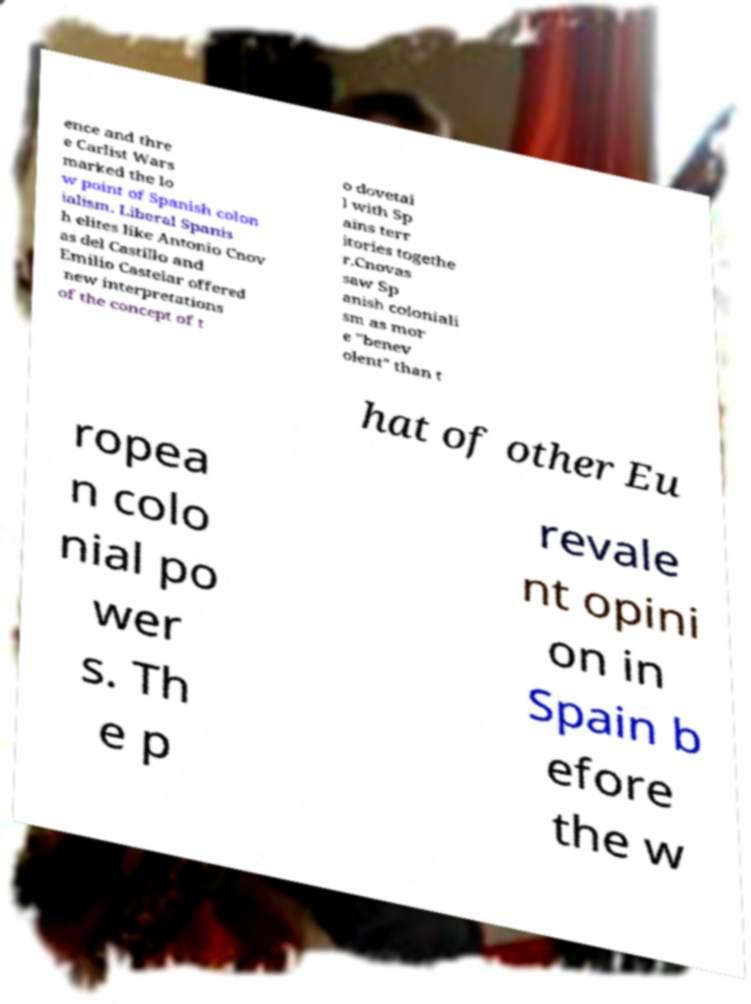For documentation purposes, I need the text within this image transcribed. Could you provide that? ence and thre e Carlist Wars marked the lo w point of Spanish colon ialism. Liberal Spanis h elites like Antonio Cnov as del Castillo and Emilio Castelar offered new interpretations of the concept of t o dovetai l with Sp ains terr itories togethe r.Cnovas saw Sp anish coloniali sm as mor e "benev olent" than t hat of other Eu ropea n colo nial po wer s. Th e p revale nt opini on in Spain b efore the w 